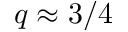Convert formula to latex. <formula><loc_0><loc_0><loc_500><loc_500>q \approx 3 / 4</formula> 